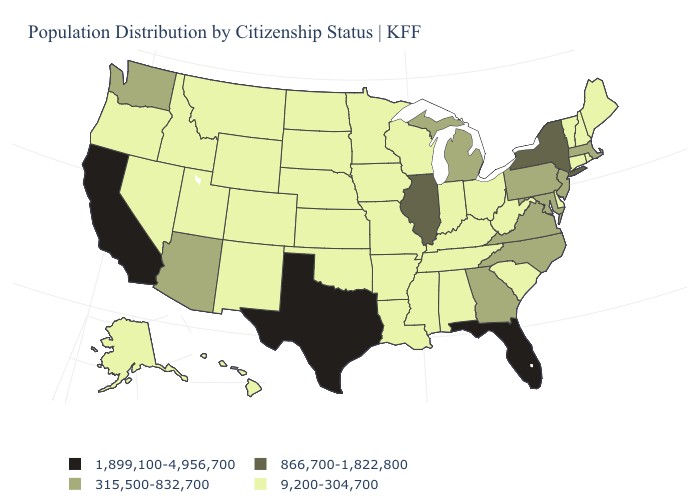What is the highest value in states that border North Carolina?
Keep it brief. 315,500-832,700. Does the map have missing data?
Write a very short answer. No. What is the value of Tennessee?
Answer briefly. 9,200-304,700. Does the map have missing data?
Quick response, please. No. Does the first symbol in the legend represent the smallest category?
Be succinct. No. Name the states that have a value in the range 866,700-1,822,800?
Be succinct. Illinois, New York. Among the states that border Illinois , which have the highest value?
Give a very brief answer. Indiana, Iowa, Kentucky, Missouri, Wisconsin. Among the states that border Montana , which have the lowest value?
Answer briefly. Idaho, North Dakota, South Dakota, Wyoming. How many symbols are there in the legend?
Keep it brief. 4. What is the value of Connecticut?
Short answer required. 9,200-304,700. What is the highest value in the MidWest ?
Give a very brief answer. 866,700-1,822,800. Which states hav the highest value in the West?
Short answer required. California. Does Delaware have a higher value than New Hampshire?
Short answer required. No. What is the highest value in the USA?
Be succinct. 1,899,100-4,956,700. What is the value of New Jersey?
Quick response, please. 315,500-832,700. 